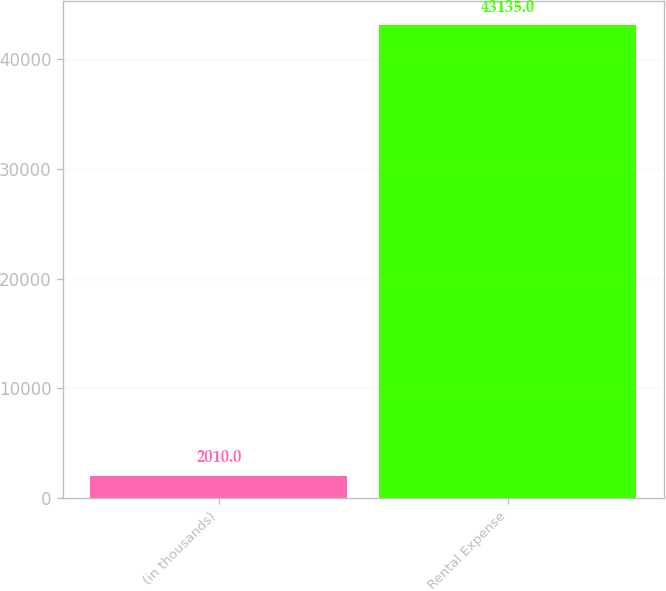<chart> <loc_0><loc_0><loc_500><loc_500><bar_chart><fcel>(in thousands)<fcel>Rental Expense<nl><fcel>2010<fcel>43135<nl></chart> 